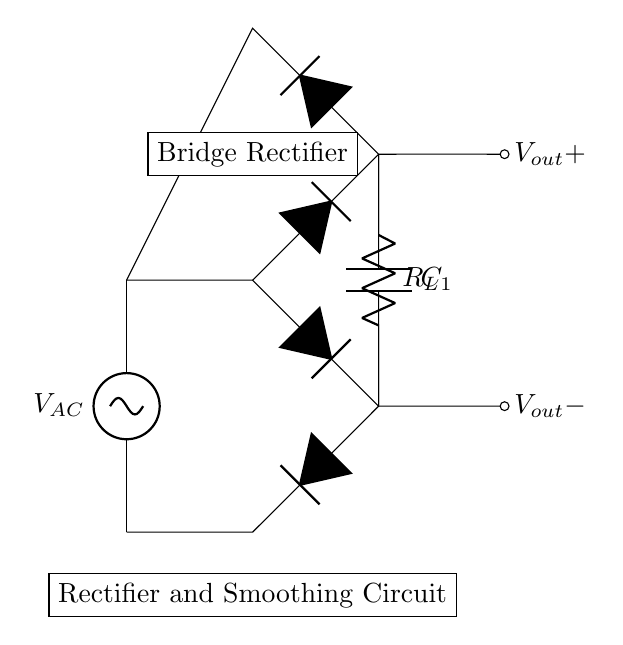What type of rectifier is used in this circuit? The circuit uses a bridge rectifier, which consists of four diodes arranged to convert AC to DC. This can be identified by the two pairs of diodes that work together in pairs to conduct during both halves of the AC cycle.
Answer: Bridge rectifier What is the purpose of the capacitor in this circuit? The capacitor, labeled C1, is used for smoothing the output voltage after rectification by reducing the ripple. It stores charge and releases it when the voltage from the rectifier drops, thereby stabilizing the output voltage.
Answer: Smoothing What does the load resistor represent in this circuit? The load resistor, labeled R_L, represents the device or appliance that uses the power supply, such as a gaming PC in this context. Its resistance determines the current flowing through the circuit based on the voltage applied.
Answer: Load What is the output voltage of the circuit, based on typical configurations? While the specific numerical value isn't given in the diagram, the output voltage (V_out) can often be approximated based on the AC input voltage minus the diode drops in a typical rectifier circuit. If we assume a common input, a rough estimate could be around 12 volts for a gaming PC power supply.
Answer: Twelve volts What is the relationship between the AC source voltage and the output voltage after rectification? The output voltage after rectification is typically less than the peak AC voltage due to the voltage drops across the diodes in the bridge rectifier and any ripple present. The relationship can be approximated using the peak input voltage minus approximately 1.4 volts (for silicon diodes).
Answer: Less than peak AC voltage How many diodes are in the bridge rectifier? There are four diodes arranged in the bridge configuration. This arrangement allows current to flow through the load in the same direction regardless of the polarity of the input AC source, effectively converting AC to DC.
Answer: Four diodes 